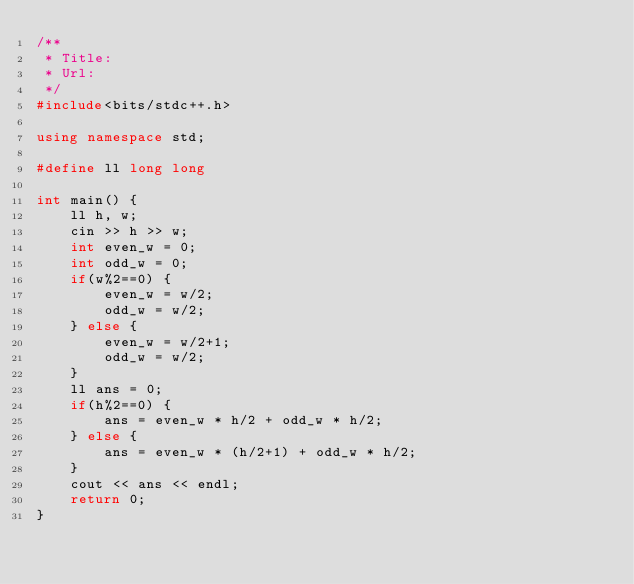<code> <loc_0><loc_0><loc_500><loc_500><_C++_>/**
 * Title:
 * Url:
 */
#include<bits/stdc++.h>

using namespace std;

#define ll long long

int main() {
    ll h, w;
    cin >> h >> w;
    int even_w = 0;
    int odd_w = 0;
    if(w%2==0) {
        even_w = w/2;
        odd_w = w/2;
    } else {
        even_w = w/2+1;
        odd_w = w/2;
    }
    ll ans = 0;
    if(h%2==0) {
        ans = even_w * h/2 + odd_w * h/2;
    } else {
        ans = even_w * (h/2+1) + odd_w * h/2;
    }
    cout << ans << endl;
    return 0;
}</code> 